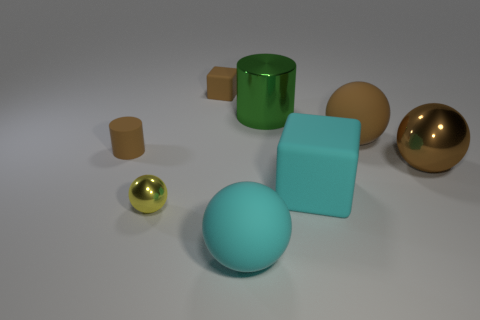Subtract 2 spheres. How many spheres are left? 2 Subtract all yellow spheres. How many spheres are left? 3 Subtract all large spheres. How many spheres are left? 1 Subtract all red spheres. Subtract all gray cubes. How many spheres are left? 4 Add 1 green cylinders. How many objects exist? 9 Subtract all cylinders. How many objects are left? 6 Subtract 0 green balls. How many objects are left? 8 Subtract all large brown metallic spheres. Subtract all small brown things. How many objects are left? 5 Add 4 big cyan rubber things. How many big cyan rubber things are left? 6 Add 2 yellow objects. How many yellow objects exist? 3 